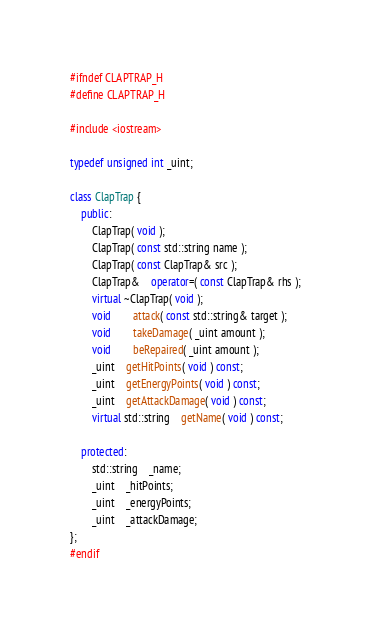Convert code to text. <code><loc_0><loc_0><loc_500><loc_500><_C++_>#ifndef CLAPTRAP_H
#define CLAPTRAP_H

#include <iostream>

typedef unsigned int _uint;

class ClapTrap {
	public:
		ClapTrap( void );
		ClapTrap( const std::string name );
		ClapTrap( const ClapTrap& src );
		ClapTrap&	operator=( const ClapTrap& rhs );
		virtual ~ClapTrap( void );
		void		attack( const std::string& target );
		void		takeDamage( _uint amount );
		void		beRepaired( _uint amount );
		_uint	getHitPoints( void ) const;
		_uint	getEnergyPoints( void ) const;
		_uint	getAttackDamage( void ) const;
		virtual std::string	getName( void ) const;

	protected:
		std::string	_name;
		_uint	_hitPoints;
		_uint	_energyPoints;
		_uint	_attackDamage;
};
#endif
</code> 